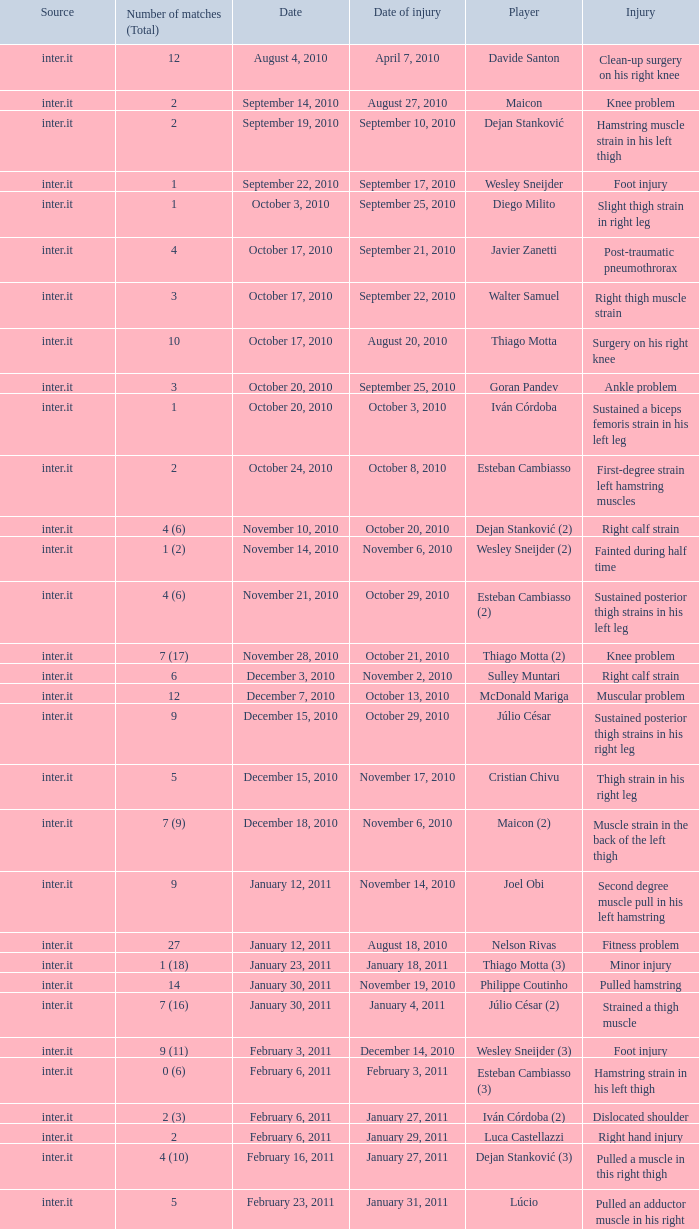What is the date of injury when the injury is foot injury and the number of matches (total) is 1? September 17, 2010. 